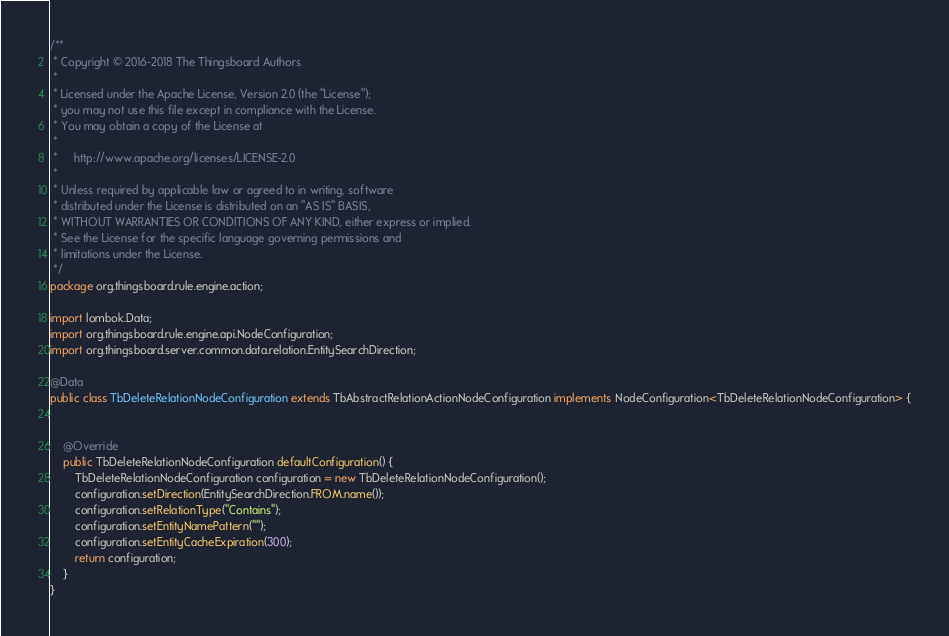Convert code to text. <code><loc_0><loc_0><loc_500><loc_500><_Java_>/**
 * Copyright © 2016-2018 The Thingsboard Authors
 *
 * Licensed under the Apache License, Version 2.0 (the "License");
 * you may not use this file except in compliance with the License.
 * You may obtain a copy of the License at
 *
 *     http://www.apache.org/licenses/LICENSE-2.0
 *
 * Unless required by applicable law or agreed to in writing, software
 * distributed under the License is distributed on an "AS IS" BASIS,
 * WITHOUT WARRANTIES OR CONDITIONS OF ANY KIND, either express or implied.
 * See the License for the specific language governing permissions and
 * limitations under the License.
 */
package org.thingsboard.rule.engine.action;

import lombok.Data;
import org.thingsboard.rule.engine.api.NodeConfiguration;
import org.thingsboard.server.common.data.relation.EntitySearchDirection;

@Data
public class TbDeleteRelationNodeConfiguration extends TbAbstractRelationActionNodeConfiguration implements NodeConfiguration<TbDeleteRelationNodeConfiguration> {


    @Override
    public TbDeleteRelationNodeConfiguration defaultConfiguration() {
        TbDeleteRelationNodeConfiguration configuration = new TbDeleteRelationNodeConfiguration();
        configuration.setDirection(EntitySearchDirection.FROM.name());
        configuration.setRelationType("Contains");
        configuration.setEntityNamePattern("");
        configuration.setEntityCacheExpiration(300);
        return configuration;
    }
}
</code> 